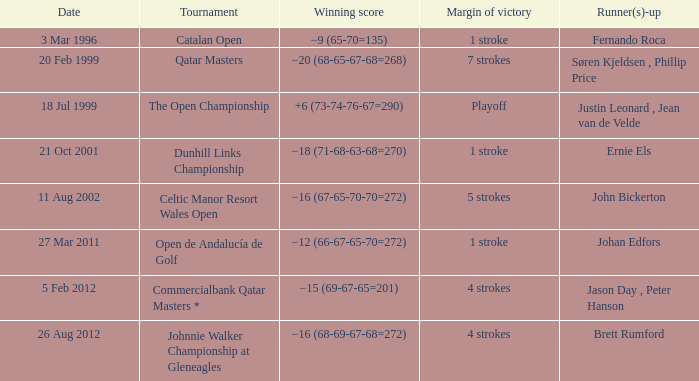What is the winning score for the runner-up Ernie Els? −18 (71-68-63-68=270). 